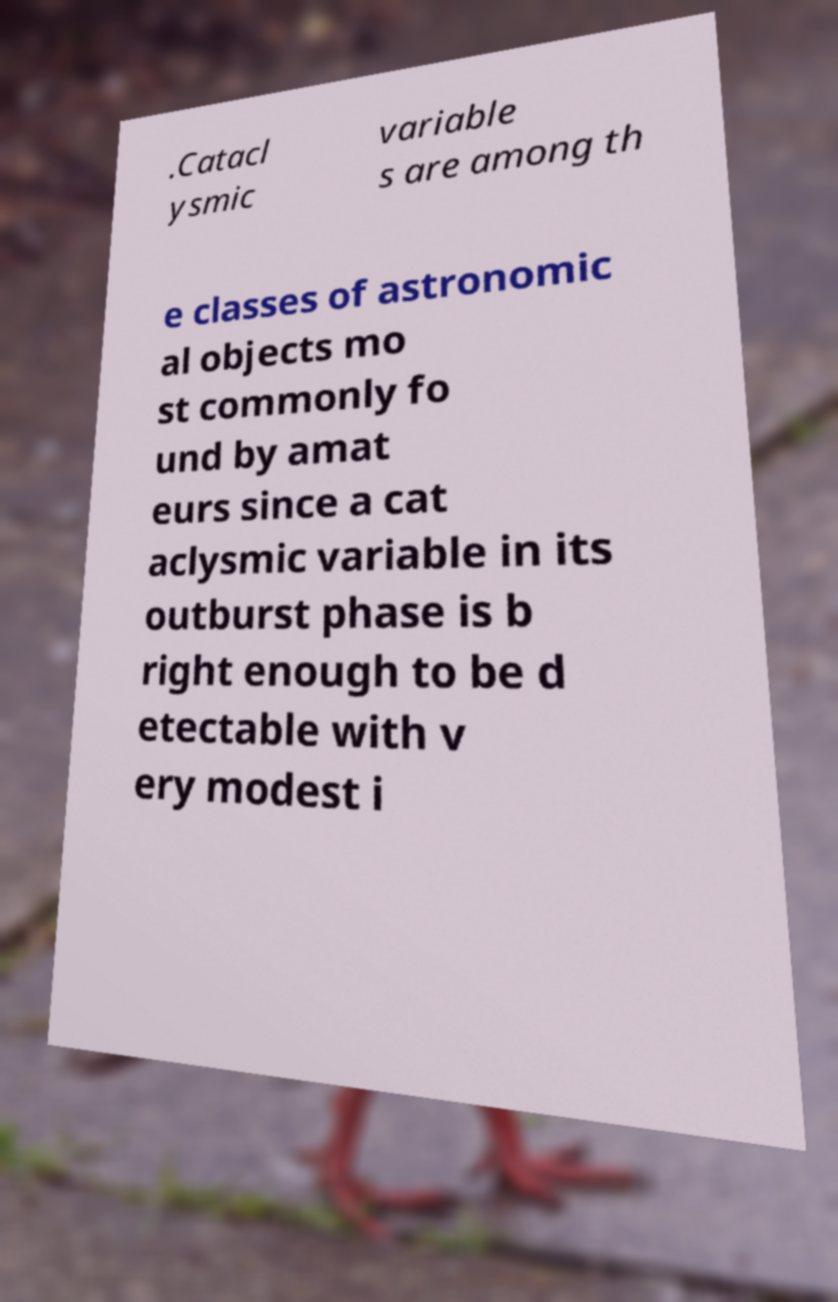I need the written content from this picture converted into text. Can you do that? .Catacl ysmic variable s are among th e classes of astronomic al objects mo st commonly fo und by amat eurs since a cat aclysmic variable in its outburst phase is b right enough to be d etectable with v ery modest i 